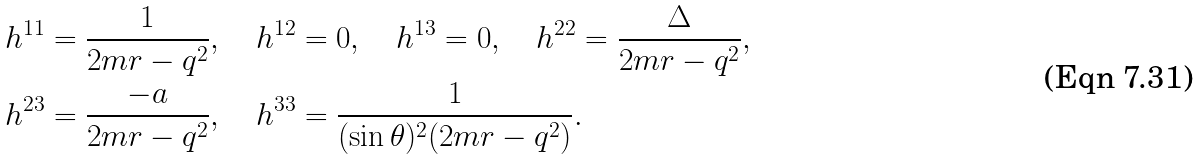Convert formula to latex. <formula><loc_0><loc_0><loc_500><loc_500>& h ^ { 1 1 } = \frac { 1 } { 2 m r - q ^ { 2 } } , \quad h ^ { 1 2 } = 0 , \quad h ^ { 1 3 } = 0 , \quad h ^ { 2 2 } = \frac { \Delta } { 2 m r - q ^ { 2 } } , \\ & h ^ { 2 3 } = \frac { - a } { 2 m r - q ^ { 2 } } , \quad h ^ { 3 3 } = \frac { 1 } { ( \sin \theta ) ^ { 2 } ( 2 m r - q ^ { 2 } ) } .</formula> 